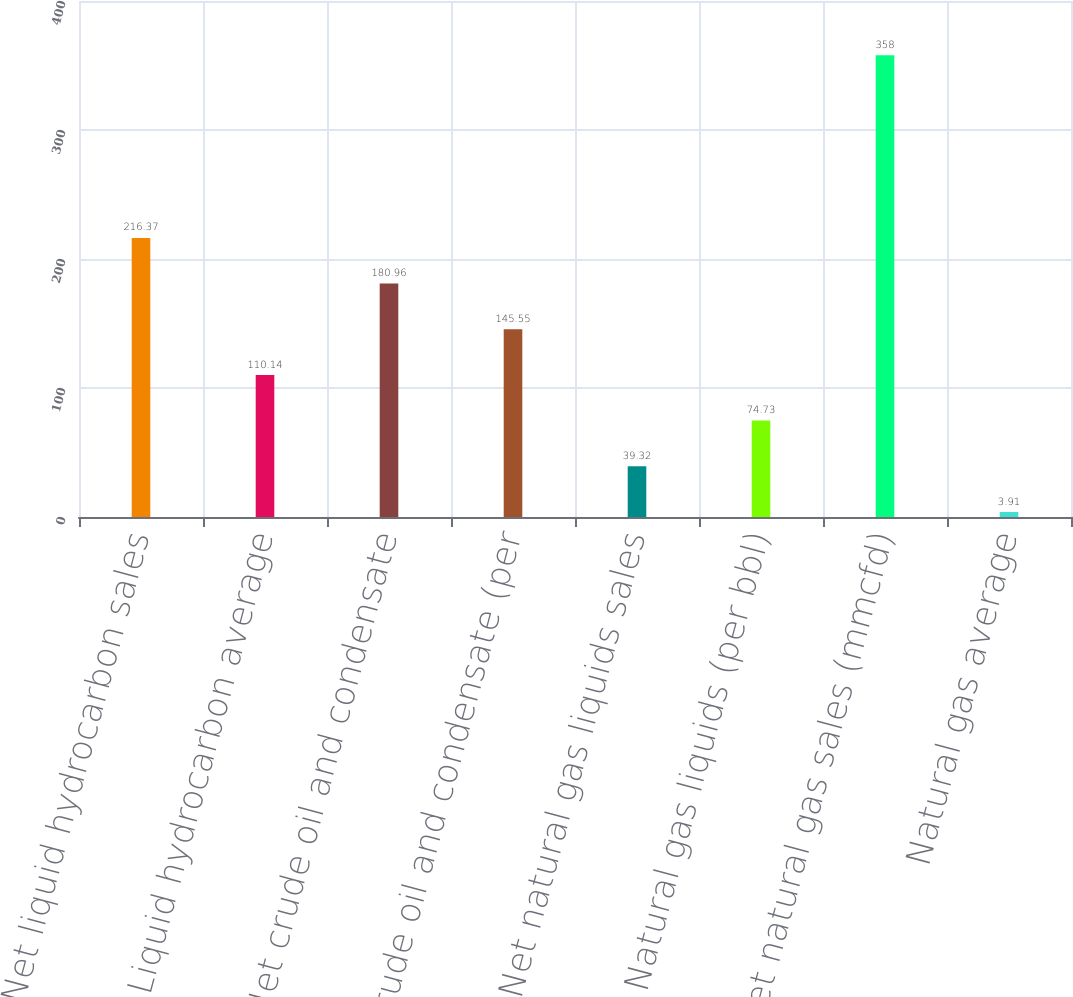Convert chart to OTSL. <chart><loc_0><loc_0><loc_500><loc_500><bar_chart><fcel>Net liquid hydrocarbon sales<fcel>Liquid hydrocarbon average<fcel>Net crude oil and condensate<fcel>Crude oil and condensate (per<fcel>Net natural gas liquids sales<fcel>Natural gas liquids (per bbl)<fcel>Net natural gas sales (mmcfd)<fcel>Natural gas average<nl><fcel>216.37<fcel>110.14<fcel>180.96<fcel>145.55<fcel>39.32<fcel>74.73<fcel>358<fcel>3.91<nl></chart> 